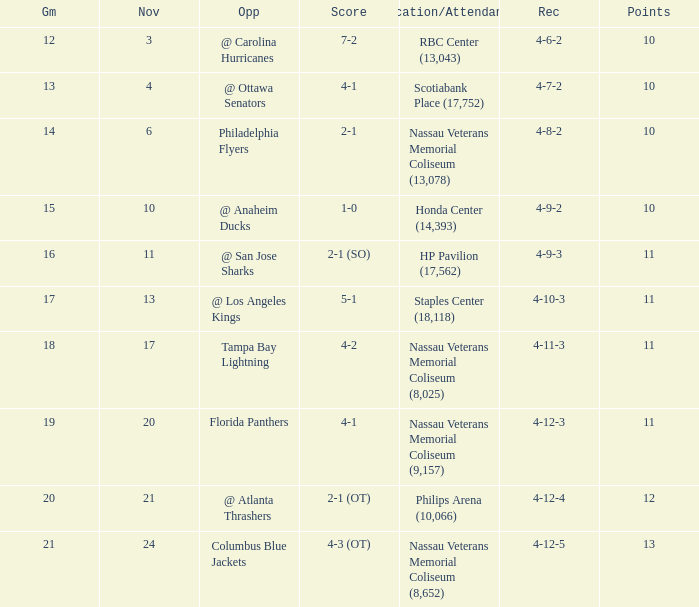What is every record for game 13? 4-7-2. 